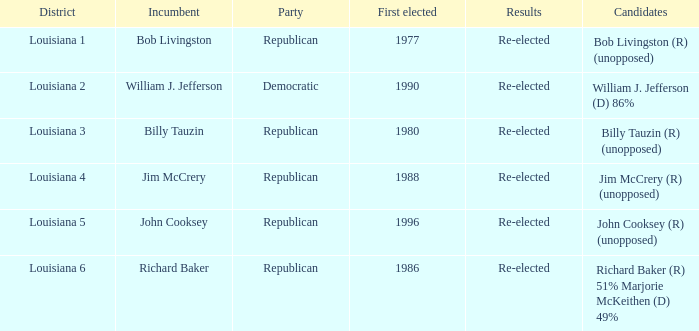What were the results for incumbent Jim McCrery? Re-elected. 